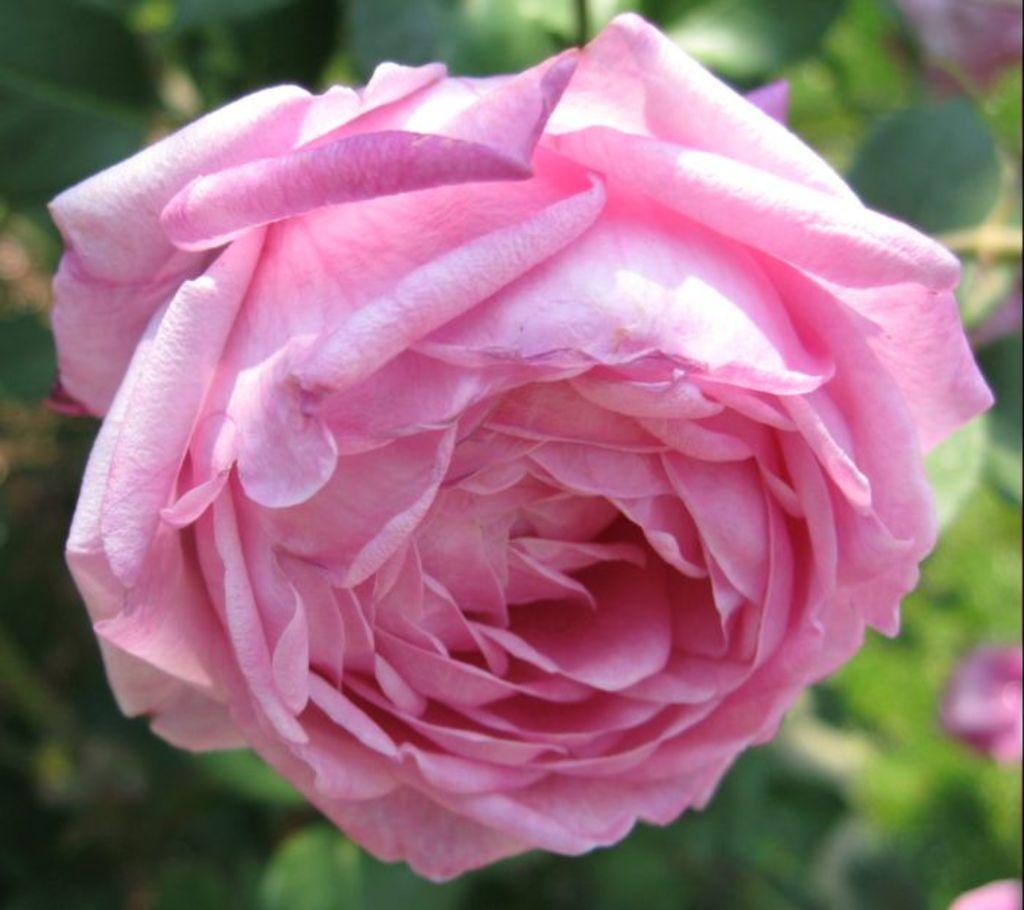Describe this image in one or two sentences. In this image there is a pink color rose flower. Background there are plants having flowers and leaves. 